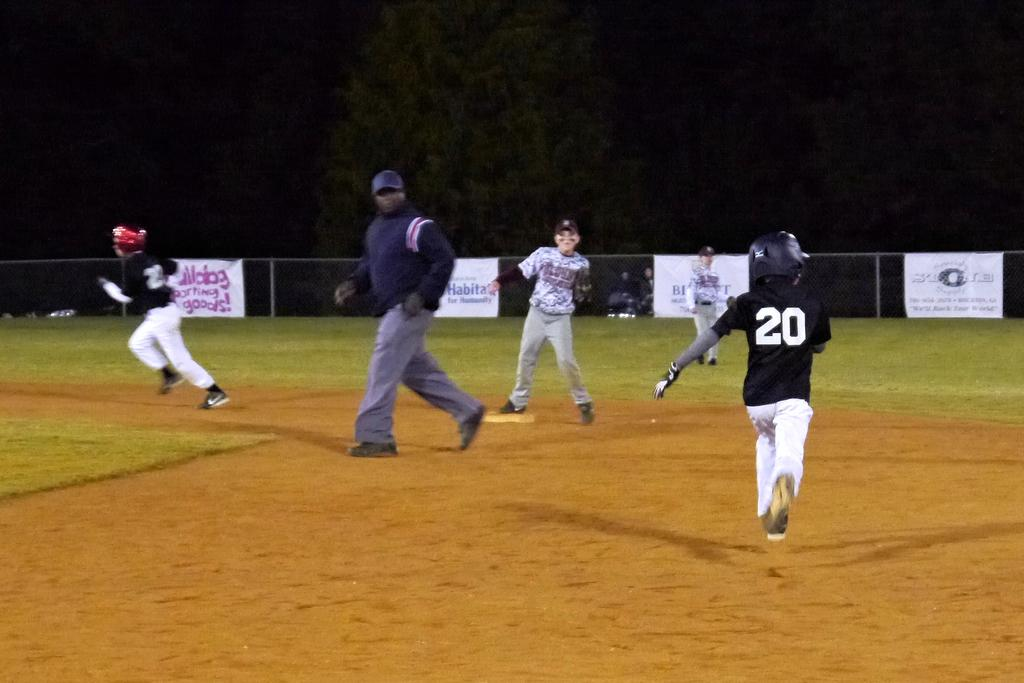<image>
Provide a brief description of the given image. A man wearing number 20 on his shirt is running to the bases. 